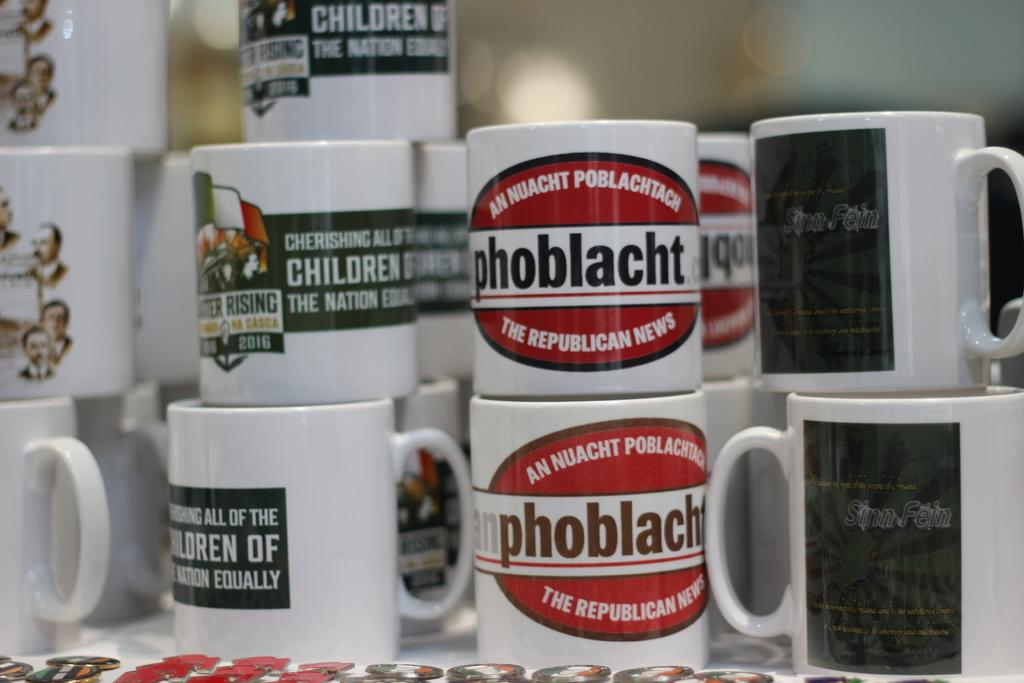<image>
Write a terse but informative summary of the picture. Red and white coffee cups have the phrase "the republican news." 